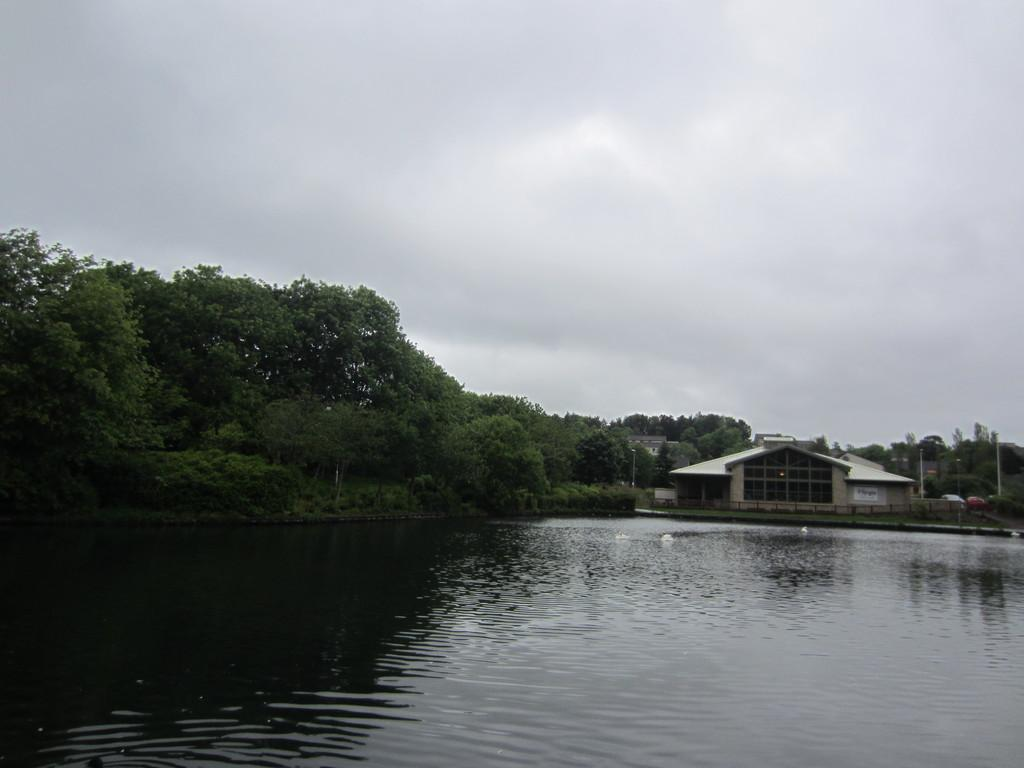Where was the image taken? The image was clicked outside, or taken, outside. What can be seen in the background of the image? There are many trees in the image. What type of structure is visible in the image? There is a house in the image. What is visible at the bottom of the image? There is water visible at the bottom of the image. What is visible in the sky at the top of the image? There are clouds in the sky at the top of the image. What type of cream is being applied to the chin in the image? There is no cream or chin present in the image; it features an outdoor scene with trees, a house, water, and clouds. 